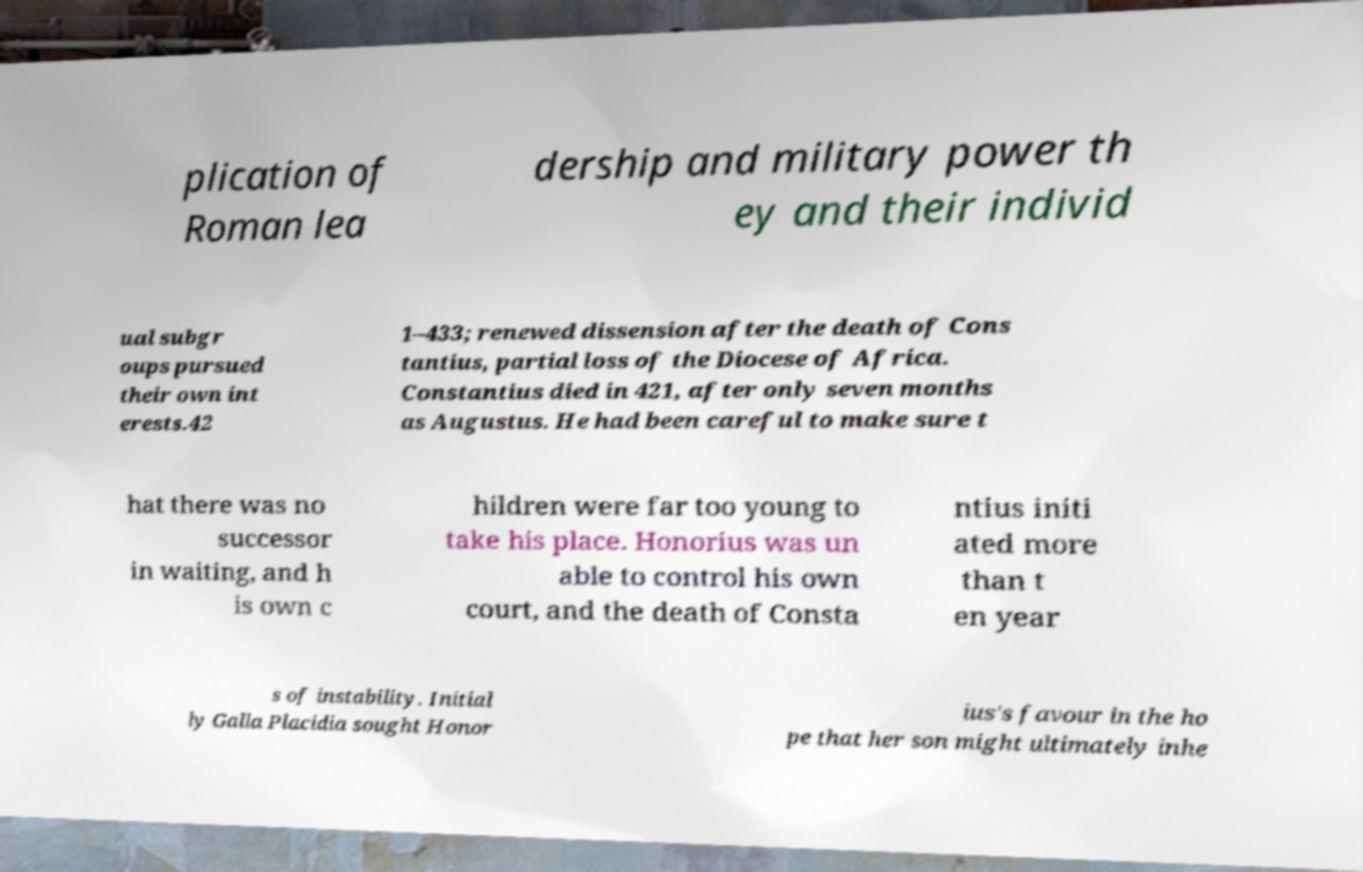Could you assist in decoding the text presented in this image and type it out clearly? plication of Roman lea dership and military power th ey and their individ ual subgr oups pursued their own int erests.42 1–433; renewed dissension after the death of Cons tantius, partial loss of the Diocese of Africa. Constantius died in 421, after only seven months as Augustus. He had been careful to make sure t hat there was no successor in waiting, and h is own c hildren were far too young to take his place. Honorius was un able to control his own court, and the death of Consta ntius initi ated more than t en year s of instability. Initial ly Galla Placidia sought Honor ius's favour in the ho pe that her son might ultimately inhe 